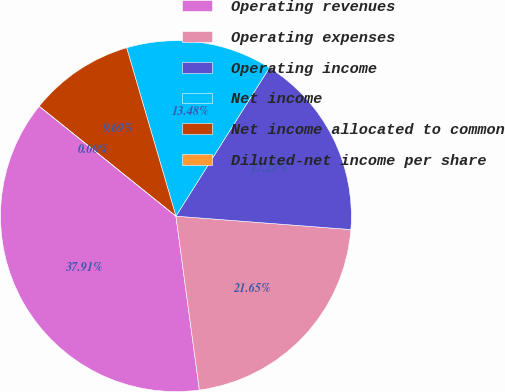<chart> <loc_0><loc_0><loc_500><loc_500><pie_chart><fcel>Operating revenues<fcel>Operating expenses<fcel>Operating income<fcel>Net income<fcel>Net income allocated to common<fcel>Diluted-net income per share<nl><fcel>37.91%<fcel>21.65%<fcel>17.27%<fcel>13.48%<fcel>9.69%<fcel>0.0%<nl></chart> 